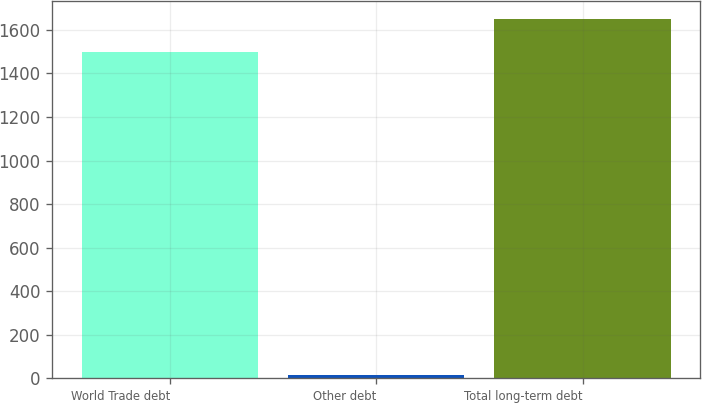Convert chart to OTSL. <chart><loc_0><loc_0><loc_500><loc_500><bar_chart><fcel>World Trade debt<fcel>Other debt<fcel>Total long-term debt<nl><fcel>1500<fcel>16<fcel>1650<nl></chart> 